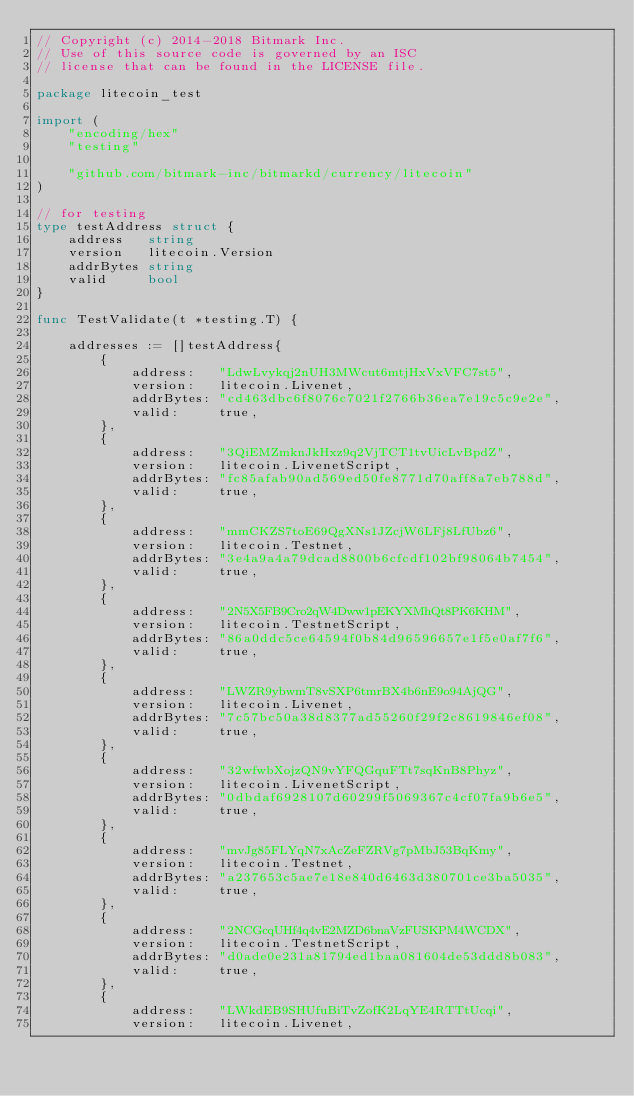<code> <loc_0><loc_0><loc_500><loc_500><_Go_>// Copyright (c) 2014-2018 Bitmark Inc.
// Use of this source code is governed by an ISC
// license that can be found in the LICENSE file.

package litecoin_test

import (
	"encoding/hex"
	"testing"

	"github.com/bitmark-inc/bitmarkd/currency/litecoin"
)

// for testing
type testAddress struct {
	address   string
	version   litecoin.Version
	addrBytes string
	valid     bool
}

func TestValidate(t *testing.T) {

	addresses := []testAddress{
		{
			address:   "LdwLvykqj2nUH3MWcut6mtjHxVxVFC7st5",
			version:   litecoin.Livenet,
			addrBytes: "cd463dbc6f8076c7021f2766b36ea7e19c5c9e2e",
			valid:     true,
		},
		{
			address:   "3QiEMZmknJkHxz9q2VjTCT1tvUicLvBpdZ",
			version:   litecoin.LivenetScript,
			addrBytes: "fc85afab90ad569ed50fe8771d70aff8a7eb788d",
			valid:     true,
		},
		{
			address:   "mmCKZS7toE69QgXNs1JZcjW6LFj8LfUbz6",
			version:   litecoin.Testnet,
			addrBytes: "3e4a9a4a79dcad8800b6cfcdf102bf98064b7454",
			valid:     true,
		},
		{
			address:   "2N5X5FB9Cro2qW4Dww1pEKYXMhQt8PK6KHM",
			version:   litecoin.TestnetScript,
			addrBytes: "86a0ddc5ce64594f0b84d96596657e1f5e0af7f6",
			valid:     true,
		},
		{
			address:   "LWZR9ybwmT8vSXP6tmrBX4b6nE9o94AjQG",
			version:   litecoin.Livenet,
			addrBytes: "7c57bc50a38d8377ad55260f29f2c8619846ef08",
			valid:     true,
		},
		{
			address:   "32wfwbXojzQN9vYFQGquFTt7sqKnB8Phyz",
			version:   litecoin.LivenetScript,
			addrBytes: "0dbdaf6928107d60299f5069367c4cf07fa9b6e5",
			valid:     true,
		},
		{
			address:   "mvJg85FLYqN7xAcZeFZRVg7pMbJ53BqKmy",
			version:   litecoin.Testnet,
			addrBytes: "a237653c5ae7e18e840d6463d380701ce3ba5035",
			valid:     true,
		},
		{
			address:   "2NCGcqUHf4q4vE2MZD6bnaVzFUSKPM4WCDX",
			version:   litecoin.TestnetScript,
			addrBytes: "d0ade0e231a81794ed1baa081604de53ddd8b083",
			valid:     true,
		},
		{
			address:   "LWkdEB9SHUfuBiTvZofK2LqYE4RTTtUcqi",
			version:   litecoin.Livenet,</code> 